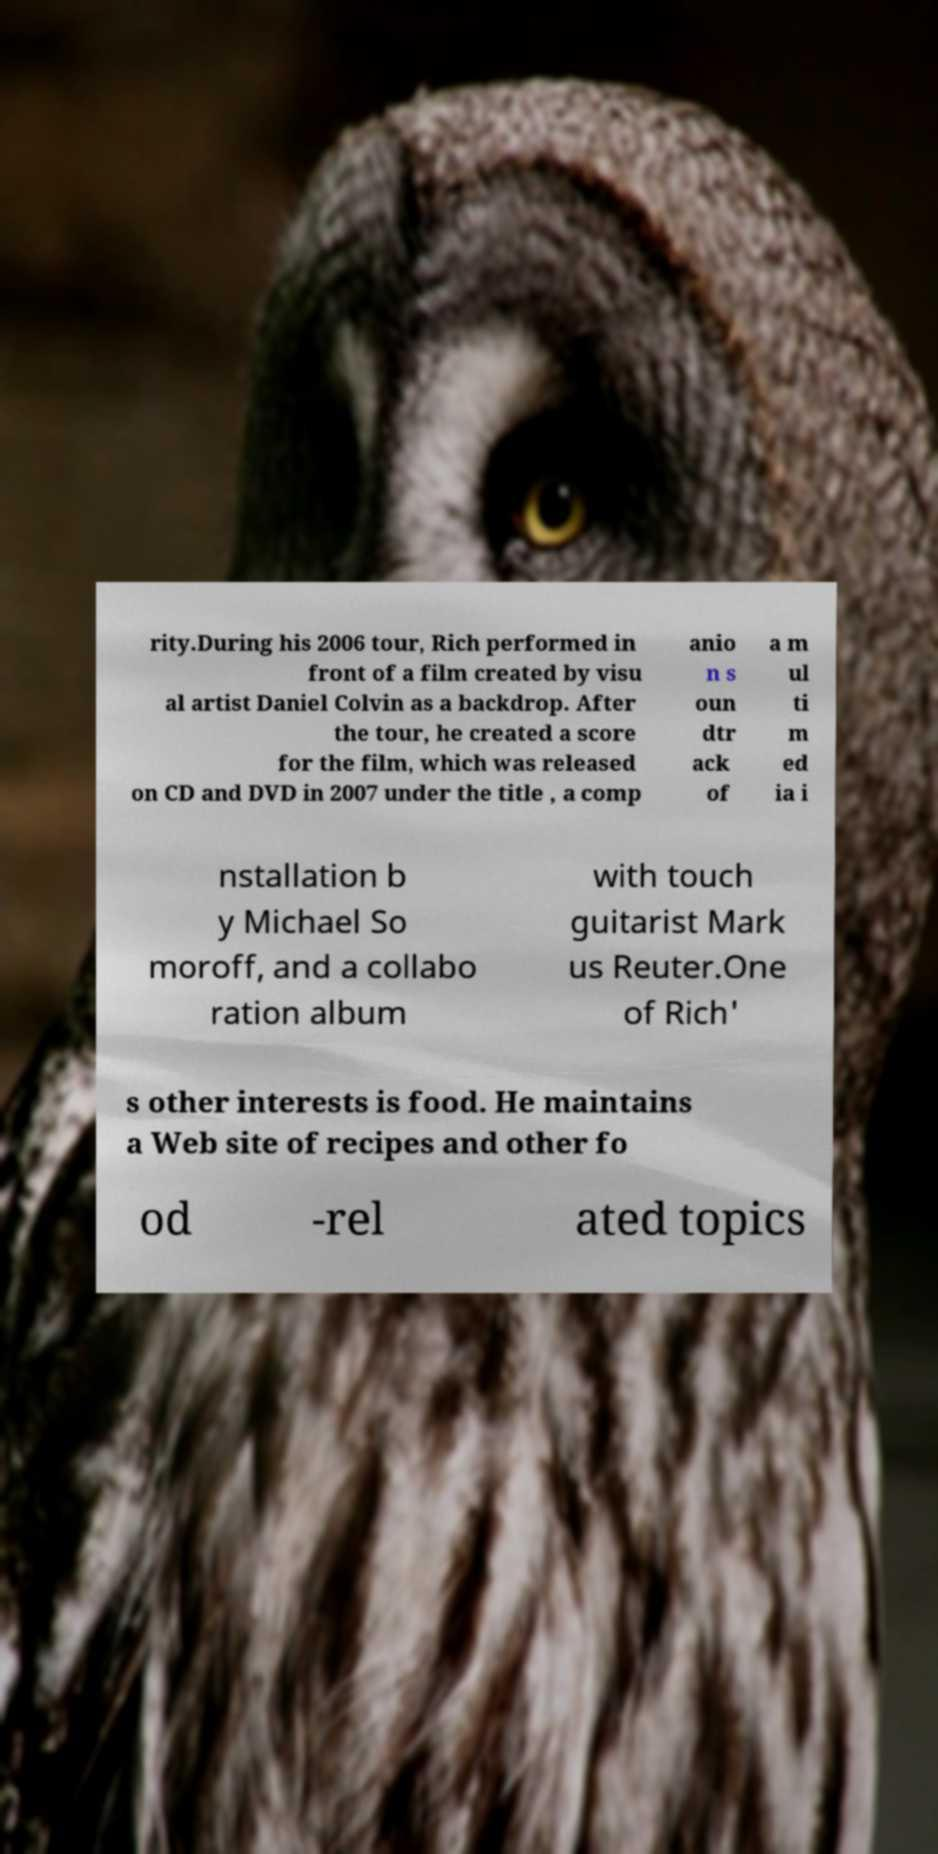There's text embedded in this image that I need extracted. Can you transcribe it verbatim? rity.During his 2006 tour, Rich performed in front of a film created by visu al artist Daniel Colvin as a backdrop. After the tour, he created a score for the film, which was released on CD and DVD in 2007 under the title , a comp anio n s oun dtr ack of a m ul ti m ed ia i nstallation b y Michael So moroff, and a collabo ration album with touch guitarist Mark us Reuter.One of Rich' s other interests is food. He maintains a Web site of recipes and other fo od -rel ated topics 